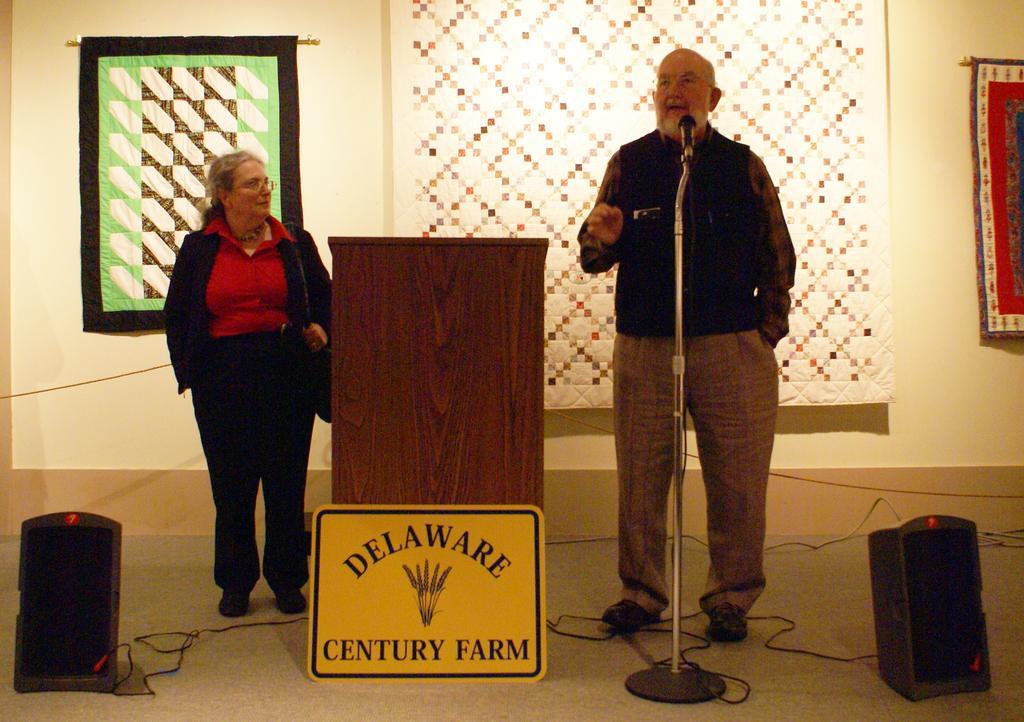Can you describe this image briefly? There is a woman in black color jacket standing on the floor near a stand which is near an yellow color board. On the right side, there is a person in black color jacket standing on the floor and speaking in front of a mic which is attached to the stand. On both sides of them, there is a speaker arranged. In the background, there are curtains hanged on the wall. 